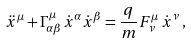<formula> <loc_0><loc_0><loc_500><loc_500>\ddot { x } ^ { \mu } + \Gamma ^ { \mu } _ { \alpha \beta } \dot { x } ^ { \alpha } \dot { x } ^ { \beta } = \frac { q } { m } F ^ { \mu } _ { \, \nu } \, \dot { x } ^ { \nu } \, ,</formula> 